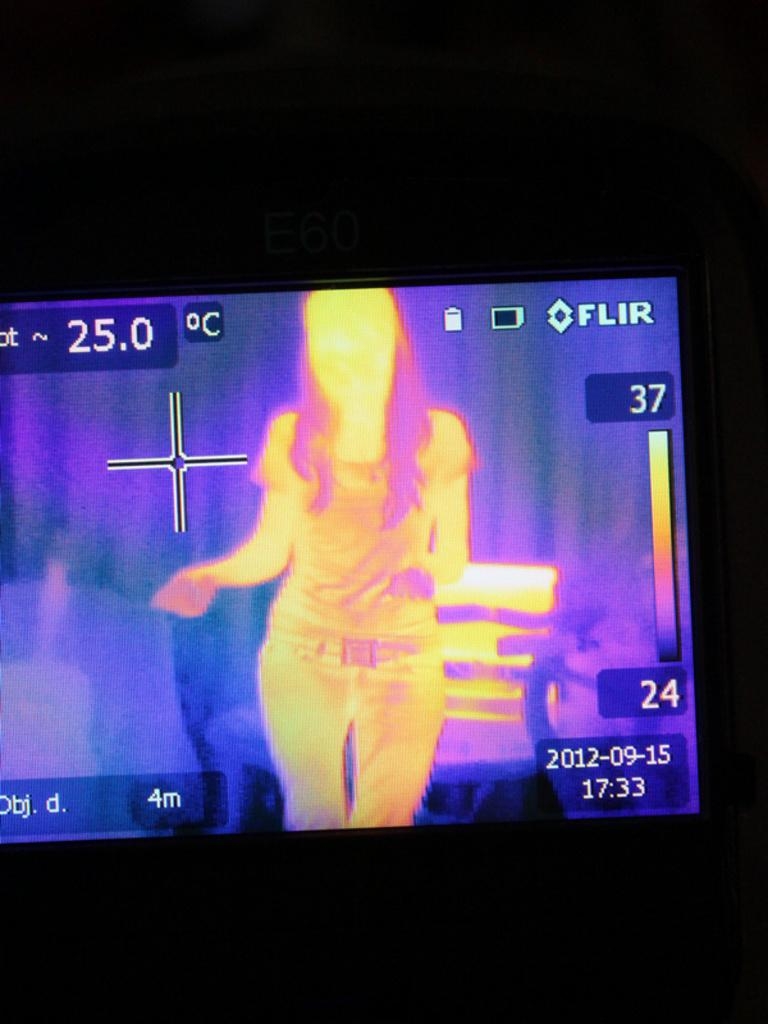What is the main object in the middle of the image? There is a screen in the middle of the image. What can be seen on the screen? An image of a person is visible on the screen, along with some text. What is the color of the background in the image? The background of the image is black. Can you see any cherries on the seashore in the image? There is no seashore or cherries present in the image; it features a screen with an image of a person and text on a black background. 